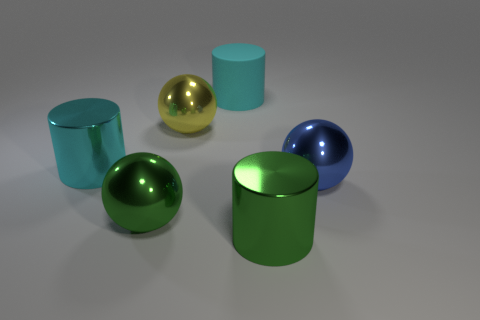Add 2 cylinders. How many objects exist? 8 Subtract 1 green cylinders. How many objects are left? 5 Subtract all cyan cylinders. Subtract all cylinders. How many objects are left? 1 Add 2 large blue things. How many large blue things are left? 3 Add 1 rubber objects. How many rubber objects exist? 2 